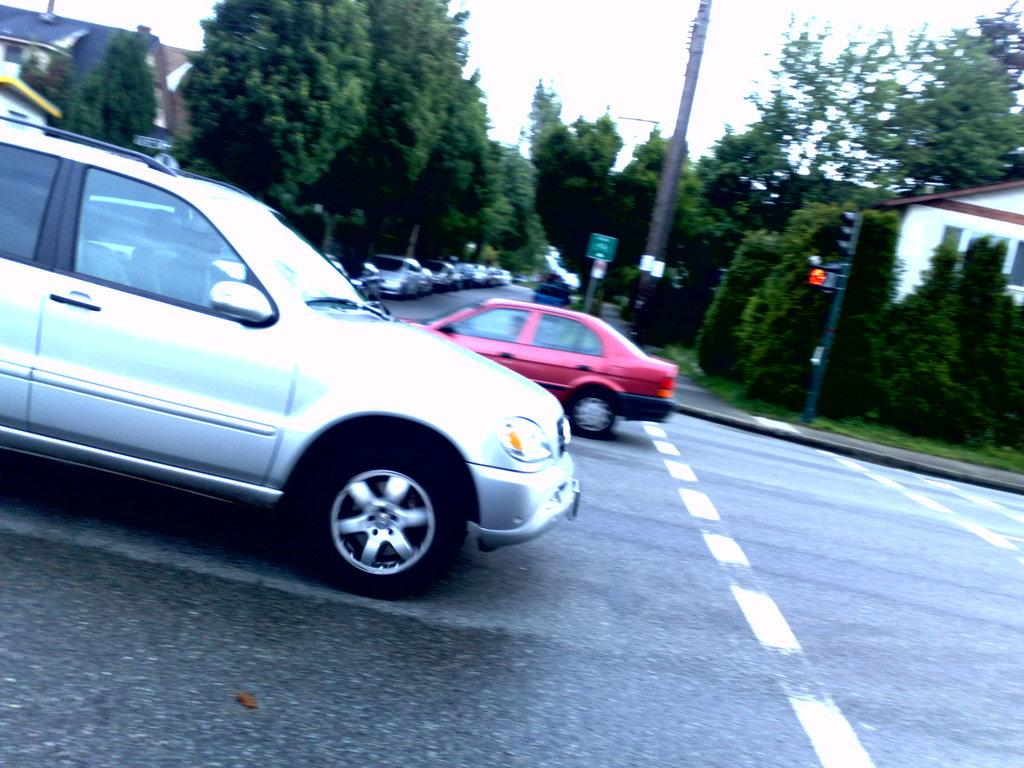What type of vehicles can be seen on the road in the image? There are motor vehicles on the road in the image. What natural elements are visible in the image? Trees are visible in the image. What structures are present to regulate traffic in the image? Traffic poles and traffic signals are visible in the image. What type of signs are present in the image? Sign boards are present in the image. What type of structures can be seen in the image? There are buildings in the image. What part of the natural environment is visible in the image? The sky is visible in the image. How does the thrill of the ride affect the motor vehicles in the image? There is no indication of a ride or thrill in the image; it simply shows motor vehicles on the road. What type of support can be seen holding up the traffic signals in the image? There is no specific type of support visible for the traffic signals in the image. Can you describe the comb used by the trees in the image? There is no comb present in the image; the trees are natural elements with leaves and branches. 